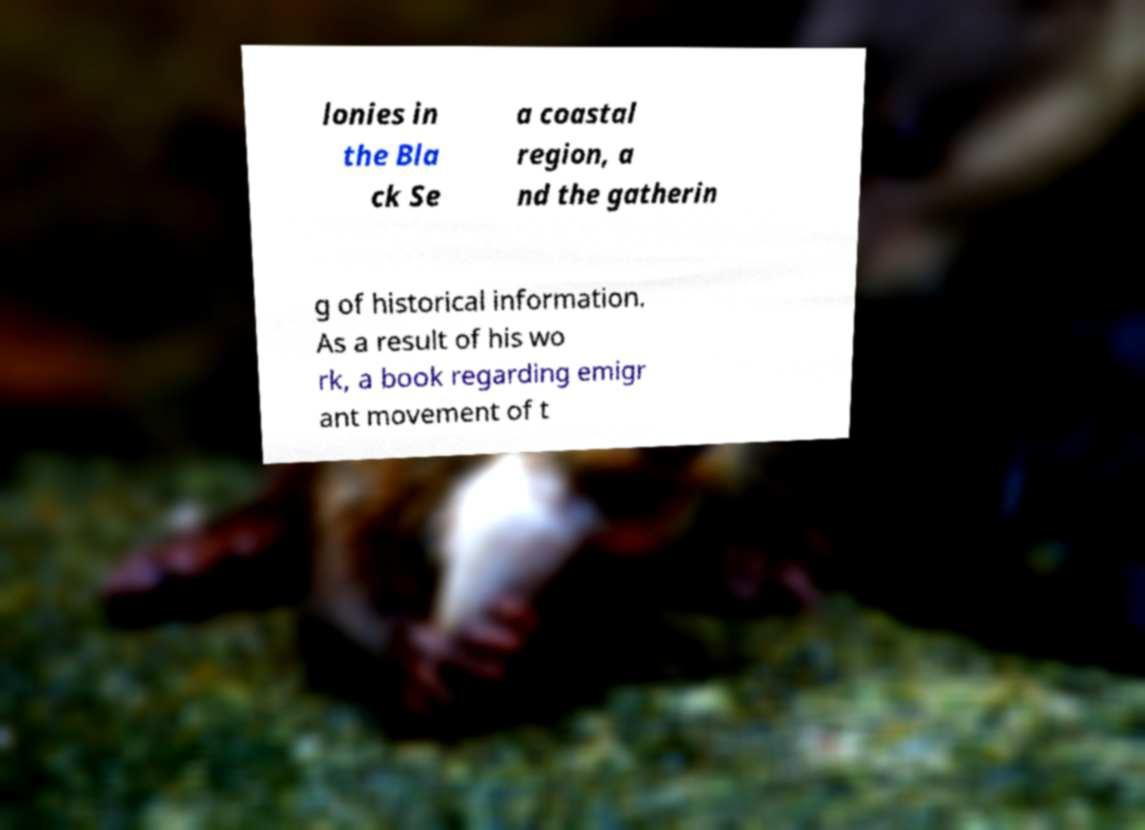Could you extract and type out the text from this image? lonies in the Bla ck Se a coastal region, a nd the gatherin g of historical information. As a result of his wo rk, a book regarding emigr ant movement of t 